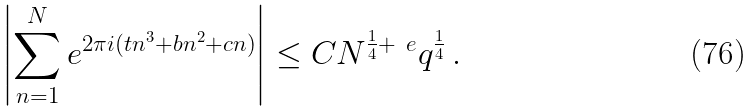Convert formula to latex. <formula><loc_0><loc_0><loc_500><loc_500>\left | \sum _ { n = 1 } ^ { N } e ^ { 2 \pi i ( t n ^ { 3 } + b n ^ { 2 } + c n ) } \right | \leq C N ^ { \frac { 1 } { 4 } + \ e } q ^ { \frac { 1 } { 4 } } \, .</formula> 